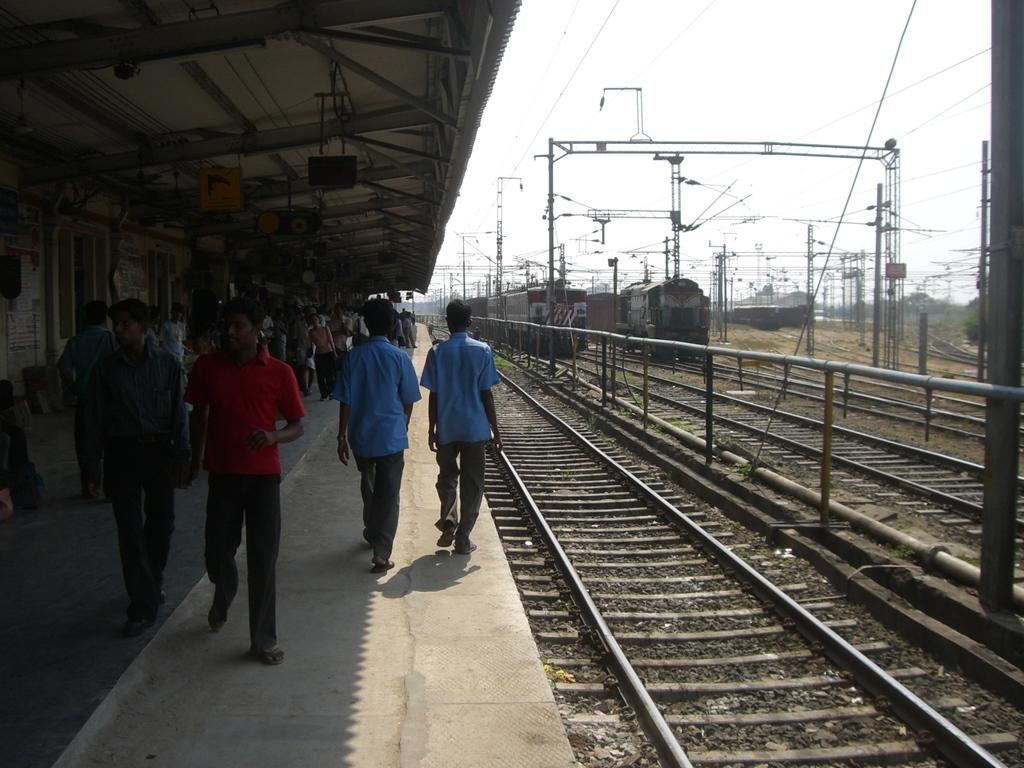What type of vehicles can be seen in the image? There are trains on a track in the image. What structures are present in the image? There are electrical poles and a platform in the image. Where is the platform located in the image? The platform is on the left side of the image. What are the people on the platform doing? People are walking on the platform. What type of covering is present on the platform? There is a roof at the top of the platform. Can you hear someone coughing in the image? There is no auditory information provided in the image, so it is impossible to determine if someone is coughing. 